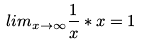<formula> <loc_0><loc_0><loc_500><loc_500>l i m _ { x \rightarrow \infty } \frac { 1 } { x } * x = 1</formula> 